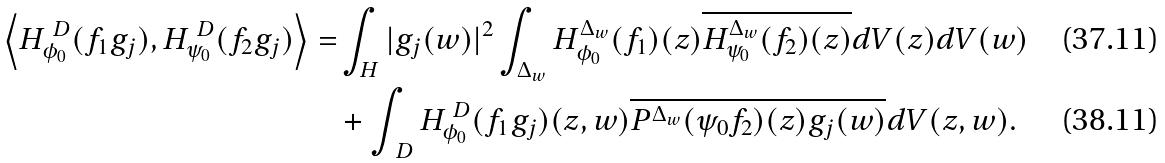<formula> <loc_0><loc_0><loc_500><loc_500>\left \langle H ^ { \ D } _ { \phi _ { 0 } } ( f _ { 1 } g _ { j } ) , H ^ { \ D } _ { \psi _ { 0 } } ( f _ { 2 } g _ { j } ) \right \rangle = & \int _ { H } | g _ { j } ( w ) | ^ { 2 } \int _ { \Delta _ { w } } H ^ { \Delta _ { w } } _ { \phi _ { 0 } } ( f _ { 1 } ) ( z ) \overline { H ^ { \Delta _ { w } } _ { \psi _ { 0 } } ( f _ { 2 } ) ( z ) } d V ( z ) d V ( w ) \\ & + \int _ { \ D } H ^ { \ D } _ { \phi _ { 0 } } ( f _ { 1 } g _ { j } ) ( z , w ) \overline { { P ^ { \Delta _ { w } } ( \psi _ { 0 } f _ { 2 } ) ( z ) } g _ { j } ( w ) } d V ( z , w ) .</formula> 